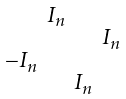Convert formula to latex. <formula><loc_0><loc_0><loc_500><loc_500>\begin{smallmatrix} & I _ { n } & & \\ & & & I _ { n } \\ - I _ { n } & & & \\ & & I _ { n } & \end{smallmatrix}</formula> 